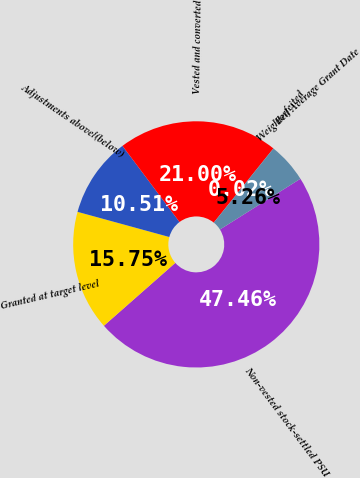Convert chart to OTSL. <chart><loc_0><loc_0><loc_500><loc_500><pie_chart><fcel>Non-vested stock-settled PSU<fcel>Granted at target level<fcel>Adjustments above/(below)<fcel>Vested and converted<fcel>Forfeited<fcel>Weighted Average Grant Date<nl><fcel>47.46%<fcel>15.75%<fcel>10.51%<fcel>21.0%<fcel>0.02%<fcel>5.26%<nl></chart> 